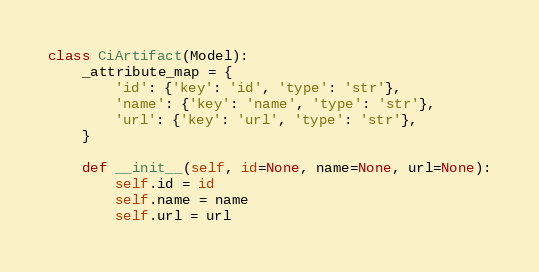<code> <loc_0><loc_0><loc_500><loc_500><_Python_>

class CiArtifact(Model):
    _attribute_map = {
        'id': {'key': 'id', 'type': 'str'},
        'name': {'key': 'name', 'type': 'str'},
        'url': {'key': 'url', 'type': 'str'},
    }

    def __init__(self, id=None, name=None, url=None):
        self.id = id
        self.name = name
        self.url = url
</code> 